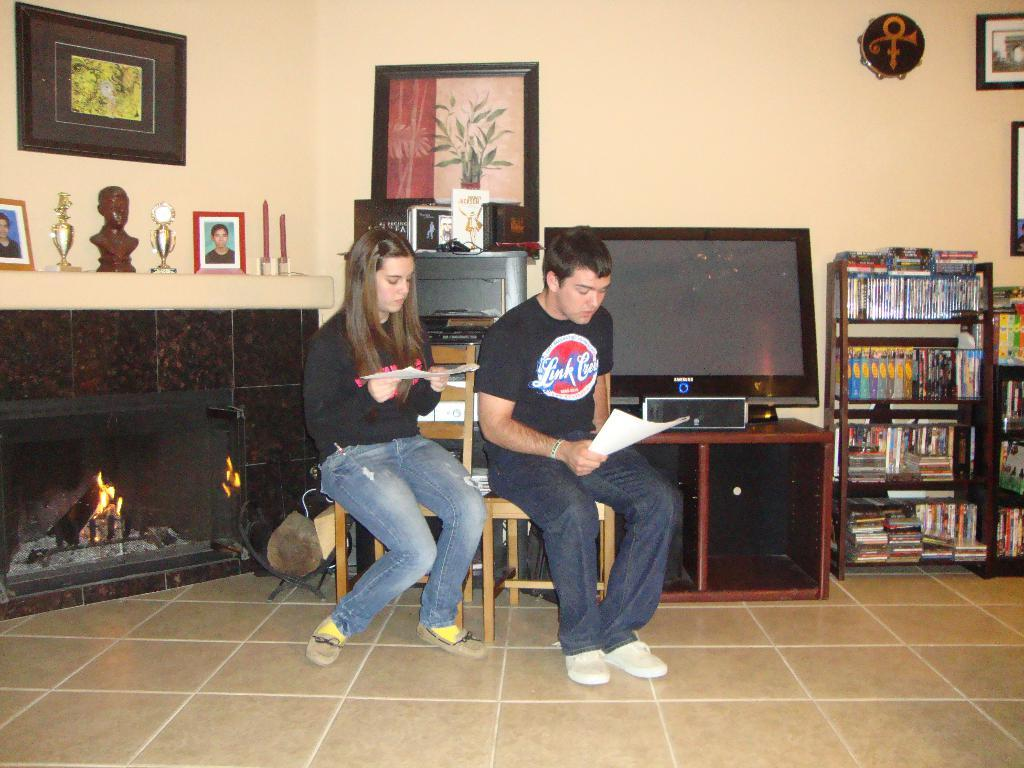How many people are in the image? There is a man and a woman in the image. What are the man and woman doing in the image? The man and woman are sitting beside each other in chairs. What can be seen in the background of the image? There is a TV and a bookshelf in the image. What type of base is supporting the blade in the image? There is no base or blade present in the image. What is the thing that the man and woman are using to communicate in the image? The image does not show any specific communication device; they might be communicating verbally or through body language. 